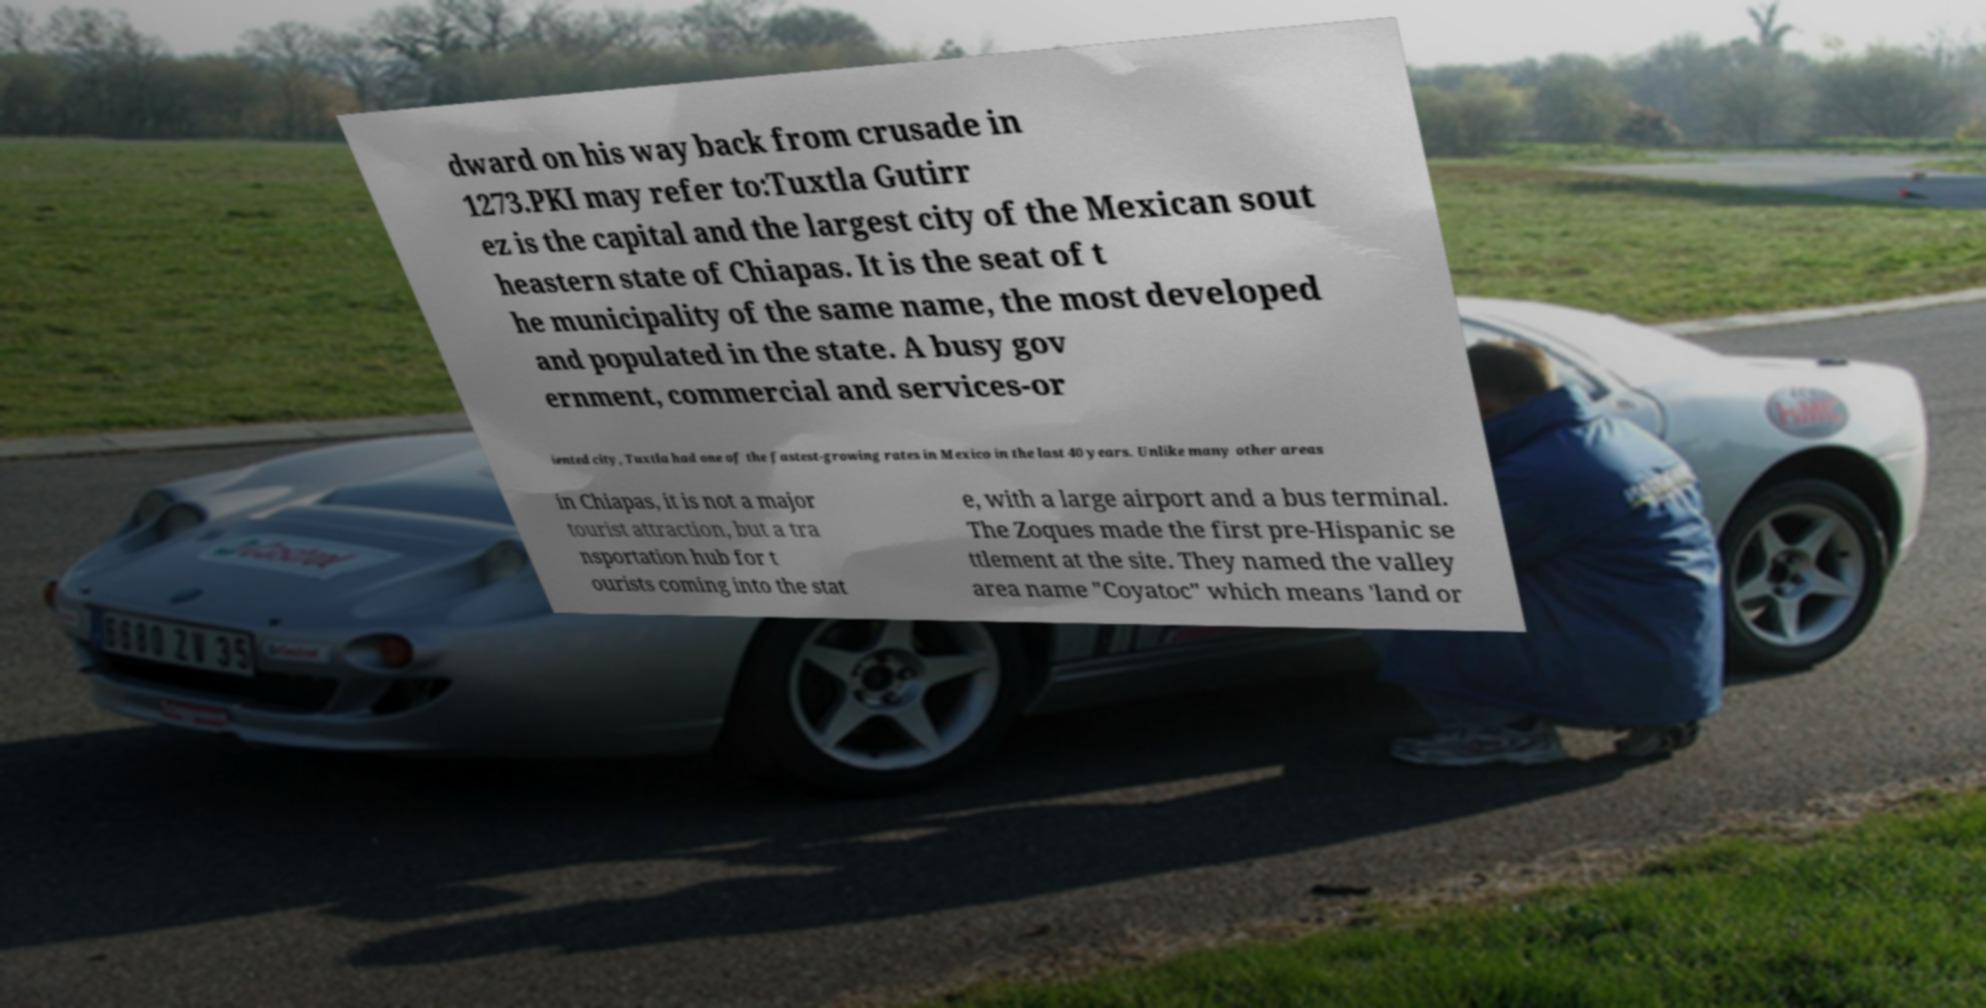Could you assist in decoding the text presented in this image and type it out clearly? dward on his way back from crusade in 1273.PKI may refer to:Tuxtla Gutirr ez is the capital and the largest city of the Mexican sout heastern state of Chiapas. It is the seat of t he municipality of the same name, the most developed and populated in the state. A busy gov ernment, commercial and services-or iented city, Tuxtla had one of the fastest-growing rates in Mexico in the last 40 years. Unlike many other areas in Chiapas, it is not a major tourist attraction, but a tra nsportation hub for t ourists coming into the stat e, with a large airport and a bus terminal. The Zoques made the first pre-Hispanic se ttlement at the site. They named the valley area name "Coyatoc" which means 'land or 